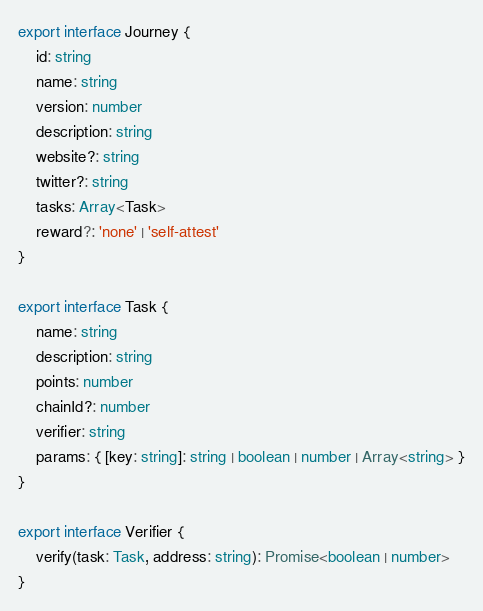Convert code to text. <code><loc_0><loc_0><loc_500><loc_500><_TypeScript_>export interface Journey {
    id: string
    name: string
    version: number
    description: string
    website?: string
    twitter?: string
    tasks: Array<Task>
    reward?: 'none' | 'self-attest'
}

export interface Task {
    name: string
    description: string
    points: number
    chainId?: number
    verifier: string
    params: { [key: string]: string | boolean | number | Array<string> }
}

export interface Verifier {
    verify(task: Task, address: string): Promise<boolean | number>
}
</code> 